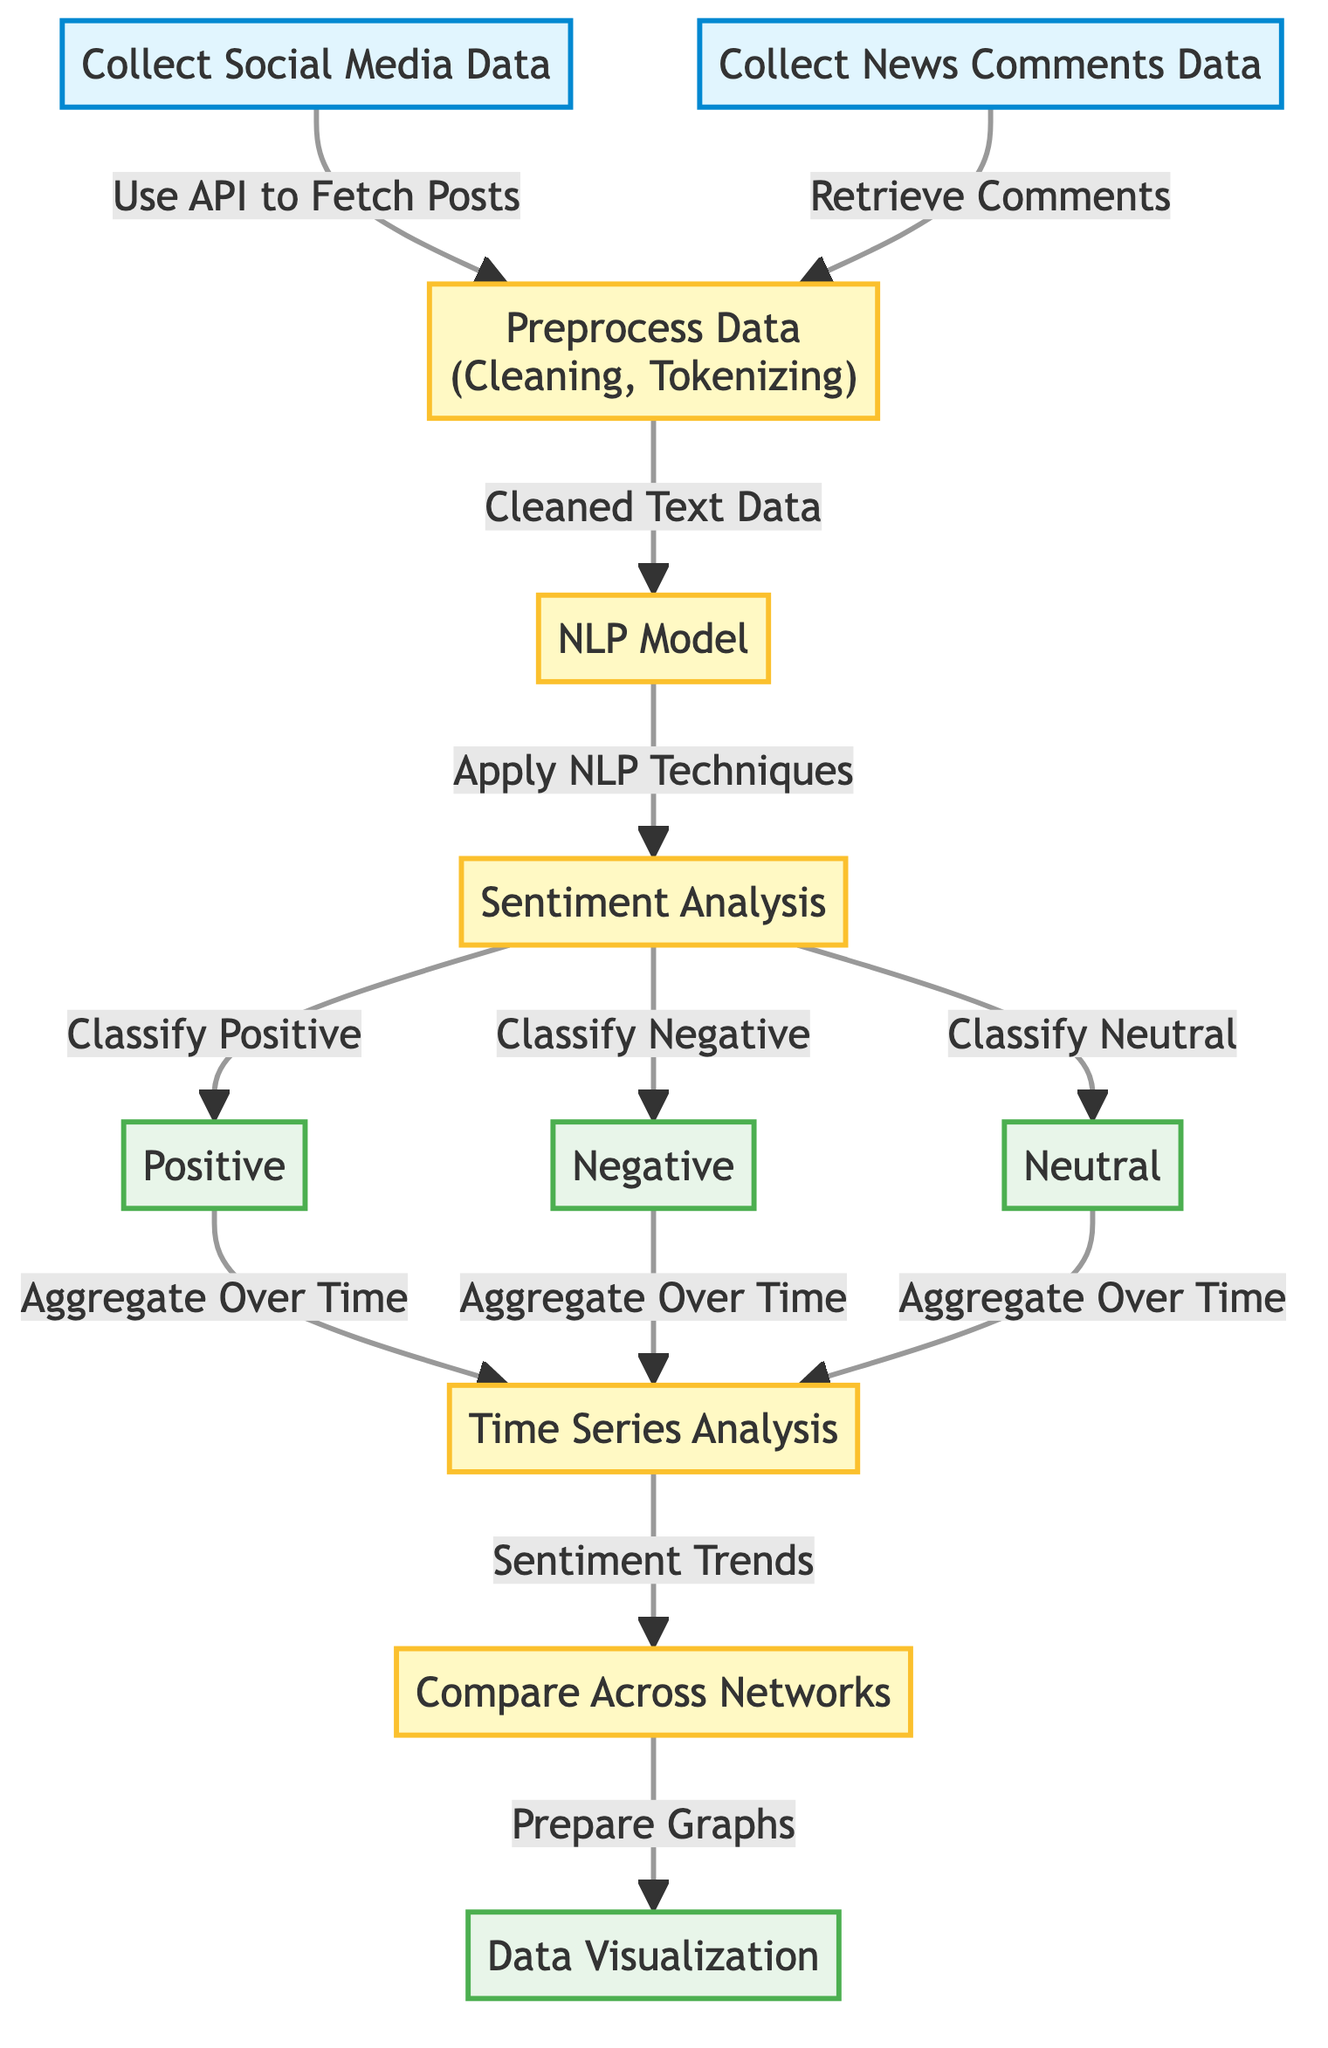What is the first step in the diagram? The diagram starts with the collection of social media data and news comments data. This is represented as two separate input nodes leading into the preprocessing step.
Answer: Collect Social Media Data How many output categories are there after sentiment analysis? After the sentiment analysis process, the classification leads to three distinct categories, which are positive, negative, and neutral.
Answer: Three What process follows after preprocessing data? Following the preprocessing data step, the cleaned text data is sent to the NLP model for analysis. This shows a sequential flow from cleaning to applying NLP techniques.
Answer: NLP Model Which node shows how to compare sentiments across different networks? The comparison of sentiments across networks is done in the "Compare Across Networks" node, which aggregates results from the time series analysis step.
Answer: Compare Across Networks What type of analysis is performed after sentiment categorization? After categorizing sentiments into positive, negative, and neutral, the next step in the flow is time series analysis which aggregates sentiments over time to observe trends.
Answer: Time Series Analysis Which two types of data are collected as inputs in the diagram? The diagram indicates two types of data that are collected as inputs which are social media data and news comments data. These are essential for initial data gathering before any processing.
Answer: Social Media Data and News Comments Data What is the final output of the diagram? The final output of the diagram is data visualization, where the processed information and trends are represented visually. This helps in conveying the sentiments categorized over time.
Answer: Data Visualization How does the sentiment analysis classify comments? Sentiment analysis classifies comments into positive, negative, and neutral categories based on the processed text data from the NLP model, showing a clear pathway from analysis to classification.
Answer: Classify Positive, Classify Negative, Classify Neutral What is the purpose of the time series analysis in the diagram? The purpose of time series analysis is to aggregate the sentiment categories over time to identify trends, allowing for a better understanding of viewer sentiment dynamics throughout the analyzed period.
Answer: Sentiment Trends 